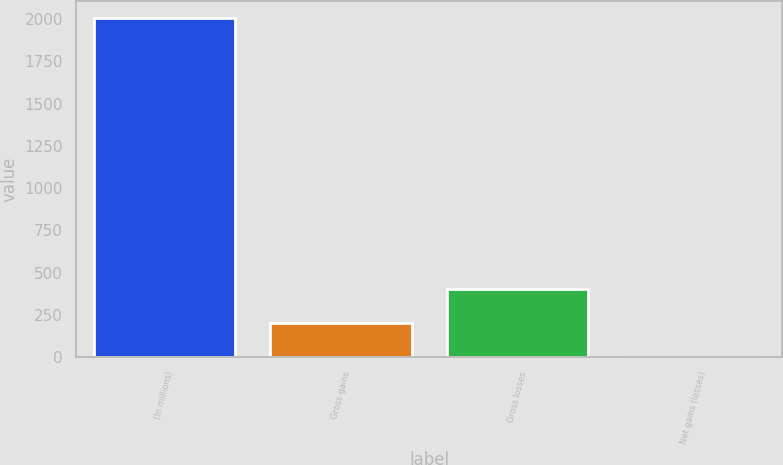Convert chart to OTSL. <chart><loc_0><loc_0><loc_500><loc_500><bar_chart><fcel>(In millions)<fcel>Gross gains<fcel>Gross losses<fcel>Net gains (losses)<nl><fcel>2005<fcel>201.4<fcel>401.8<fcel>1<nl></chart> 